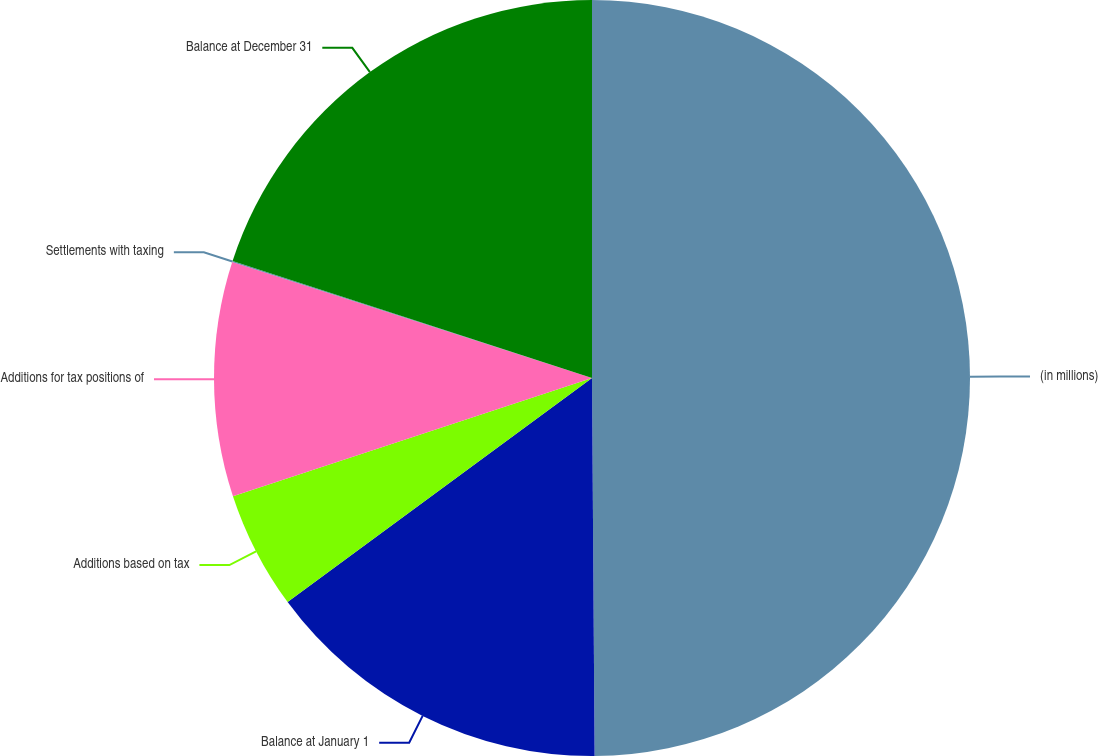Convert chart to OTSL. <chart><loc_0><loc_0><loc_500><loc_500><pie_chart><fcel>(in millions)<fcel>Balance at January 1<fcel>Additions based on tax<fcel>Additions for tax positions of<fcel>Settlements with taxing<fcel>Balance at December 31<nl><fcel>49.89%<fcel>15.01%<fcel>5.04%<fcel>10.02%<fcel>0.05%<fcel>19.99%<nl></chart> 